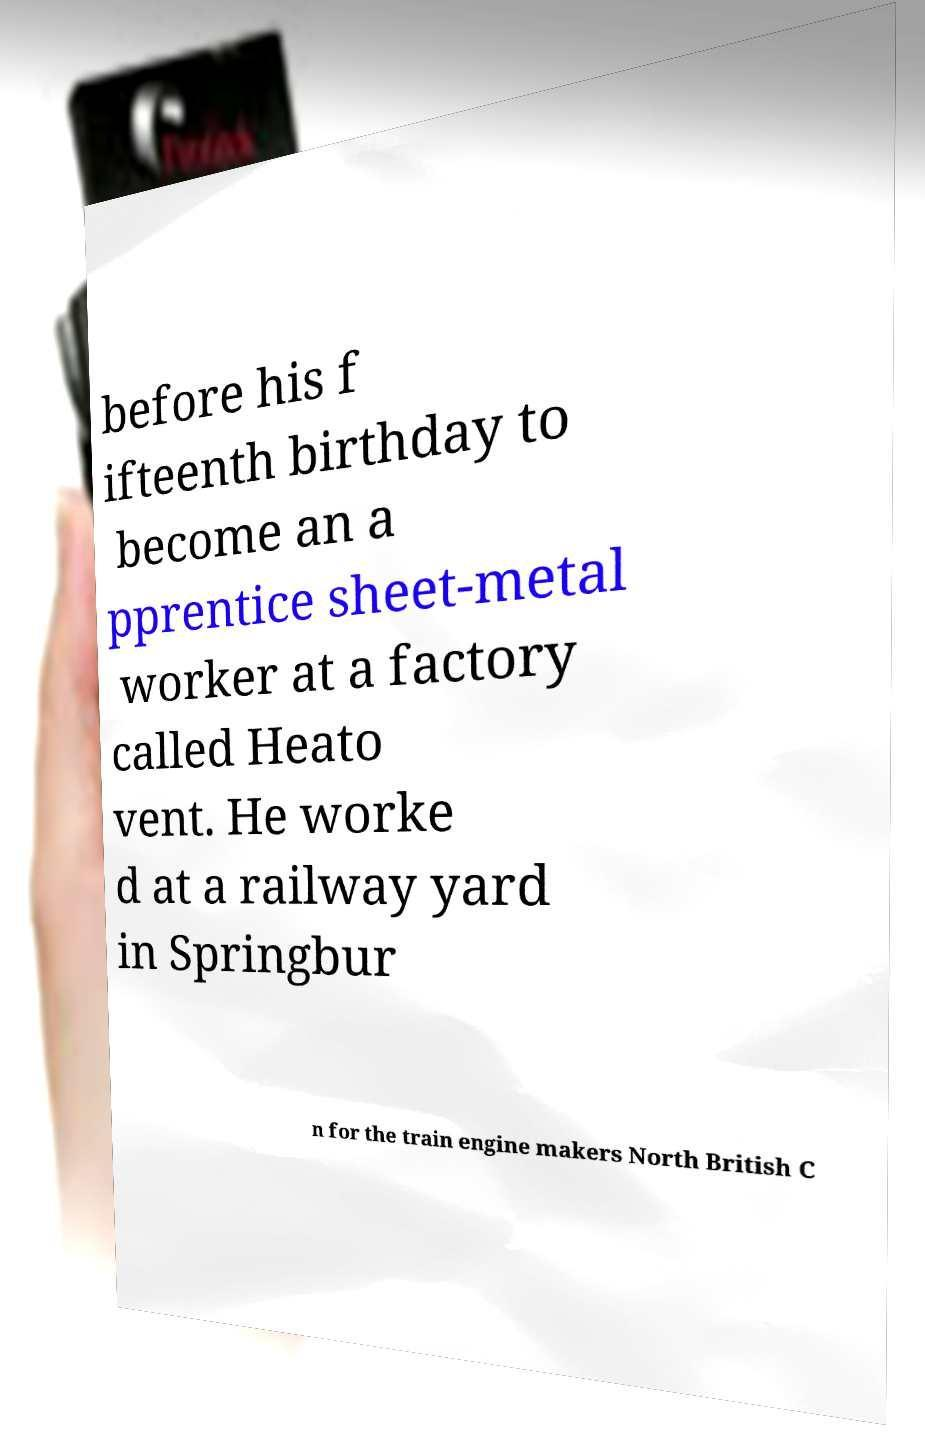What messages or text are displayed in this image? I need them in a readable, typed format. before his f ifteenth birthday to become an a pprentice sheet-metal worker at a factory called Heato vent. He worke d at a railway yard in Springbur n for the train engine makers North British C 